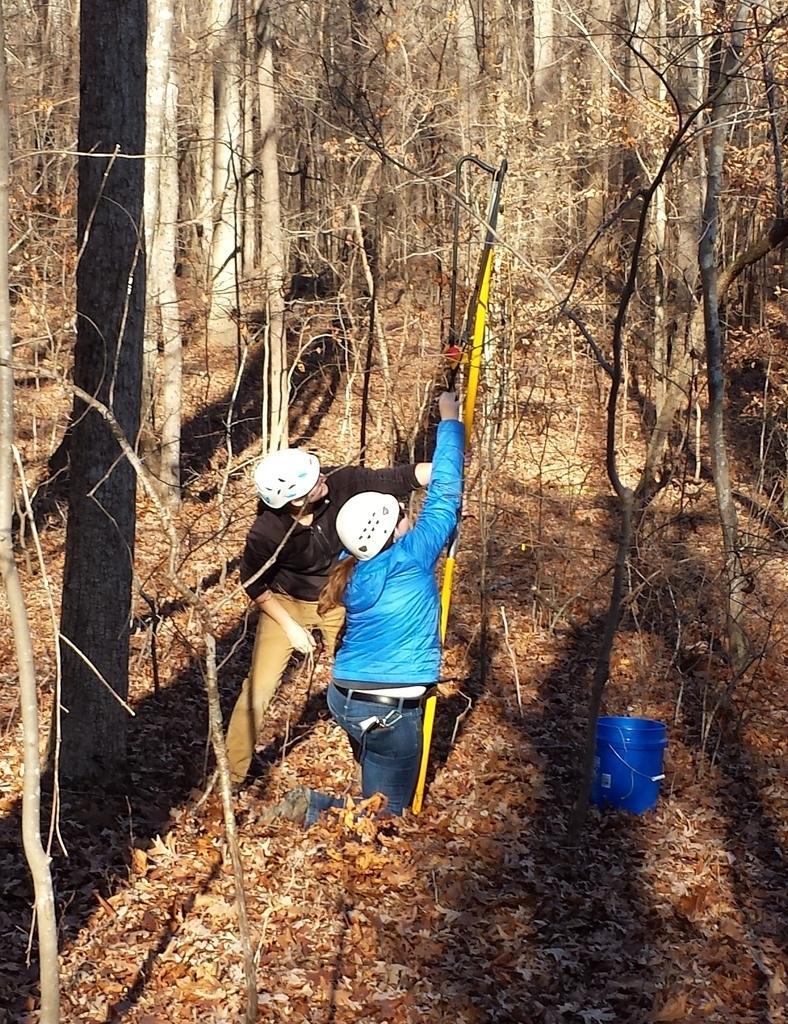In one or two sentences, can you explain what this image depicts? In the foreground of the picture there are dry leaves, bucket, trees and two women. In the background there are trees. 